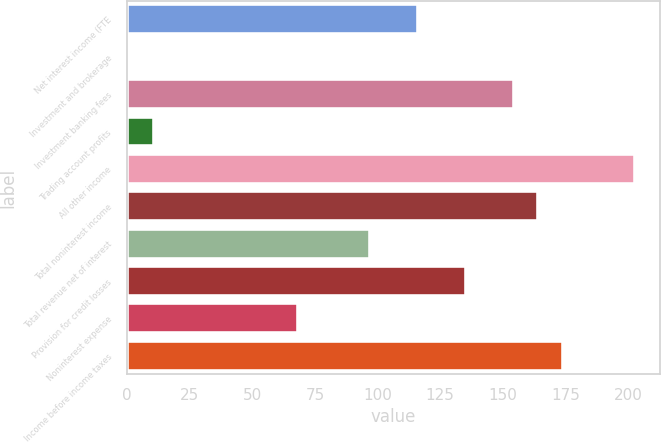<chart> <loc_0><loc_0><loc_500><loc_500><bar_chart><fcel>Net interest income (FTE<fcel>Investment and brokerage<fcel>Investment banking fees<fcel>Trading account profits<fcel>All other income<fcel>Total noninterest income<fcel>Total revenue net of interest<fcel>Provision for credit losses<fcel>Noninterest expense<fcel>Income before income taxes<nl><fcel>116.2<fcel>1<fcel>154.6<fcel>10.6<fcel>202.6<fcel>164.2<fcel>97<fcel>135.4<fcel>68.2<fcel>173.8<nl></chart> 